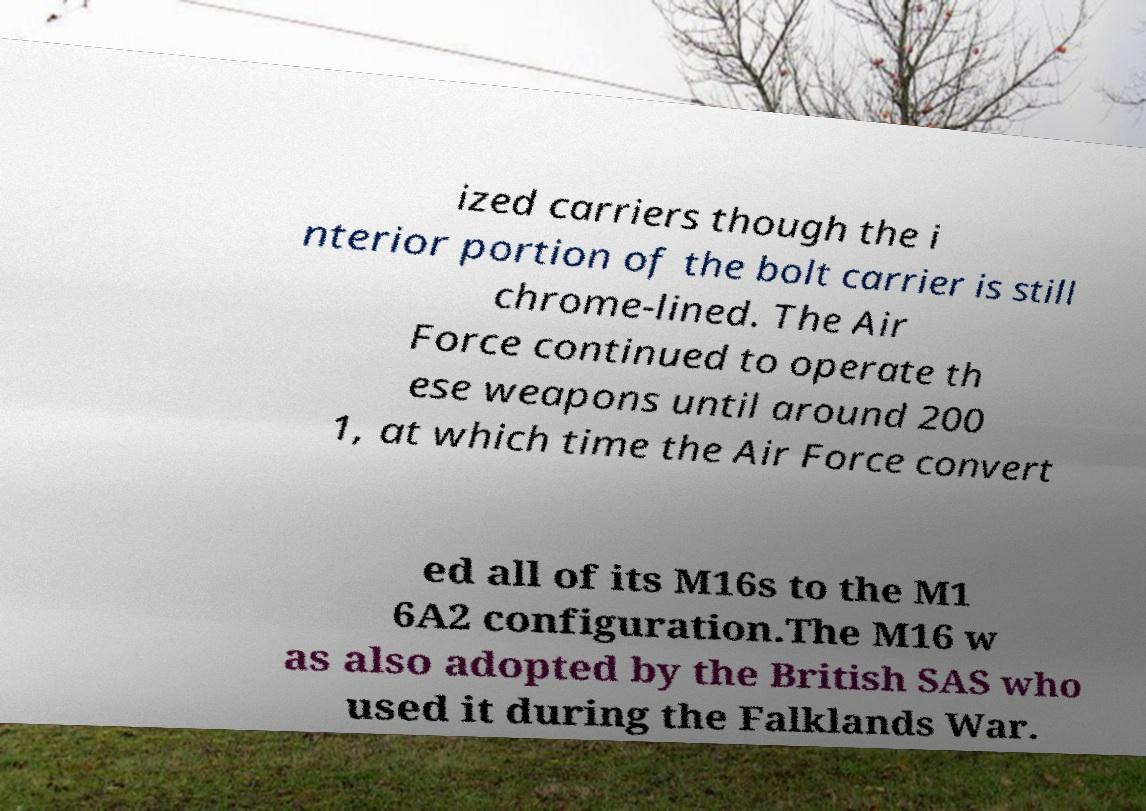Could you extract and type out the text from this image? ized carriers though the i nterior portion of the bolt carrier is still chrome-lined. The Air Force continued to operate th ese weapons until around 200 1, at which time the Air Force convert ed all of its M16s to the M1 6A2 configuration.The M16 w as also adopted by the British SAS who used it during the Falklands War. 